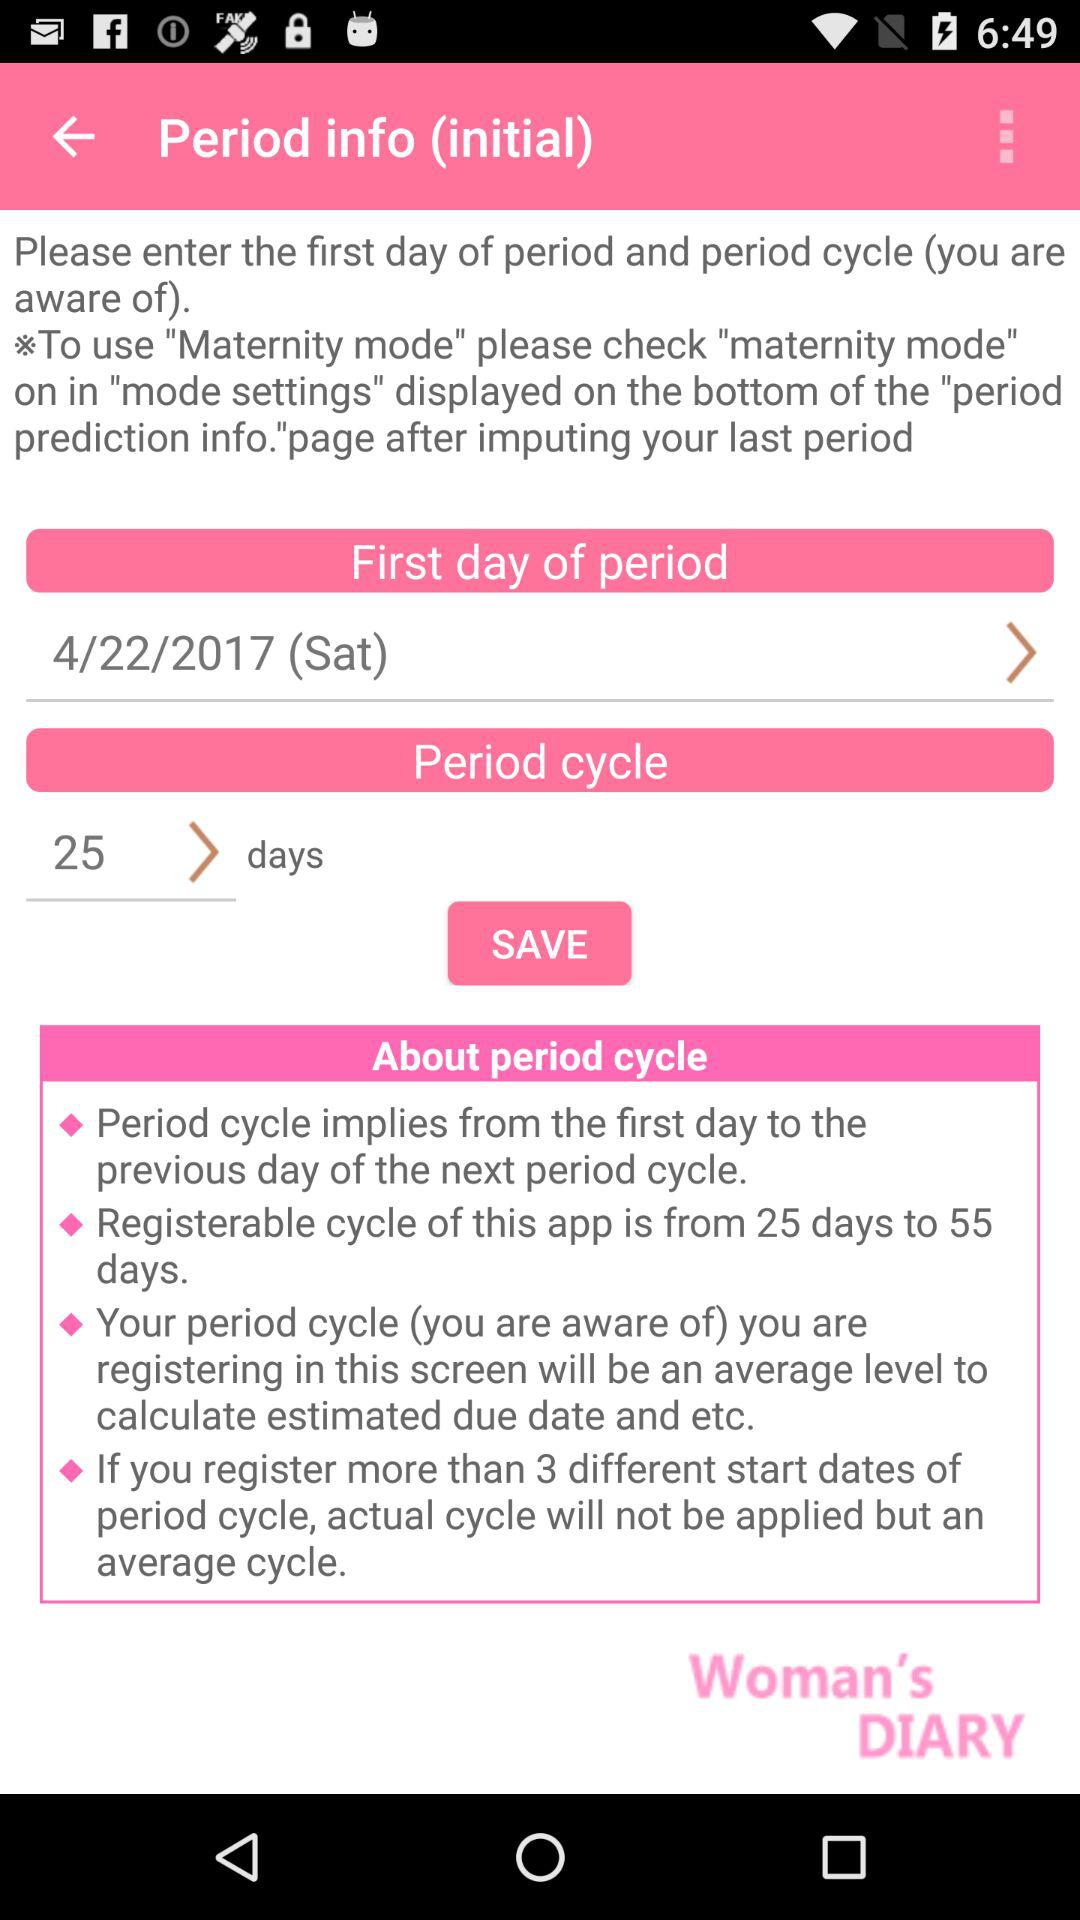When did the period get started? The period got started on Saturday, April 22, 2017. 